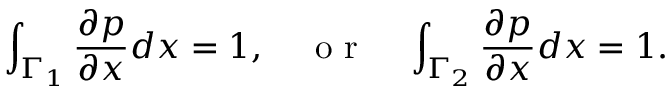<formula> <loc_0><loc_0><loc_500><loc_500>\int _ { \Gamma _ { 1 } } \frac { \partial p } { \partial x } d x = 1 , o r \int _ { \Gamma _ { 2 } } \frac { \partial p } { \partial x } d x = 1 .</formula> 